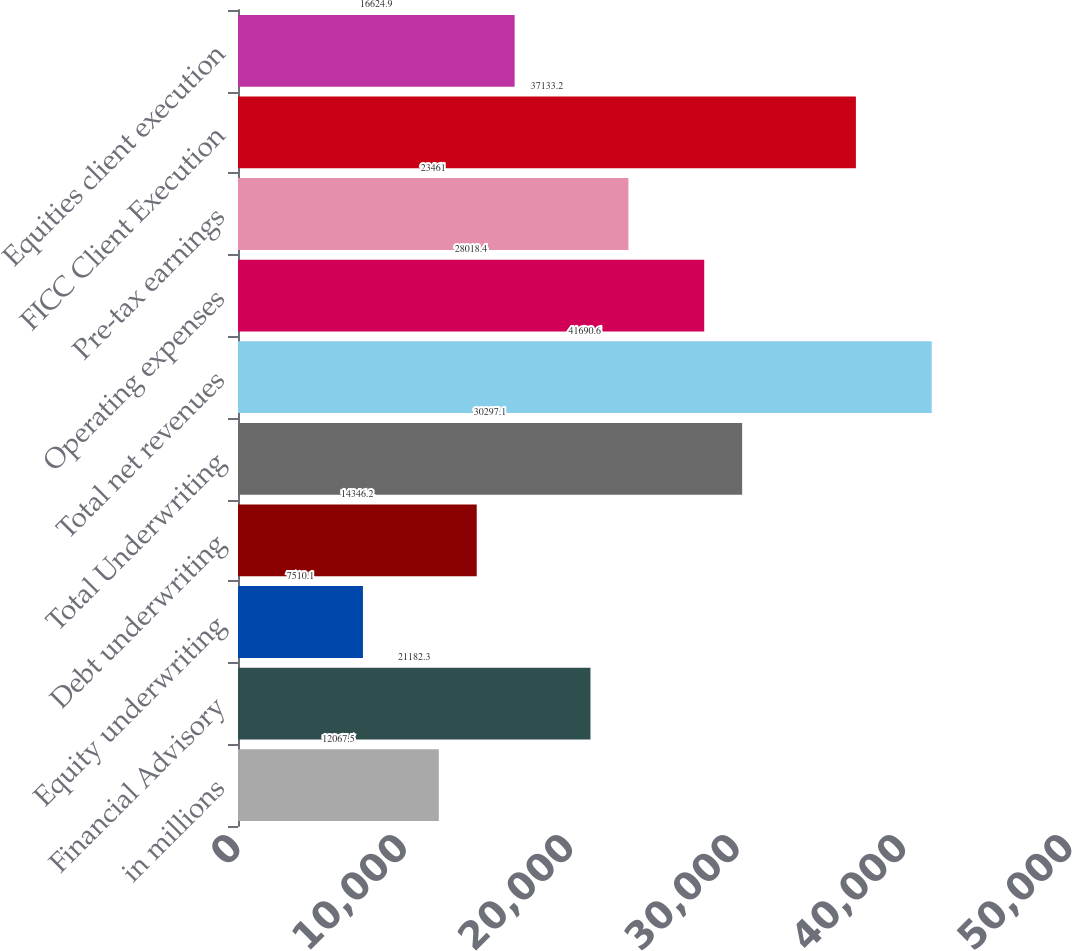<chart> <loc_0><loc_0><loc_500><loc_500><bar_chart><fcel>in millions<fcel>Financial Advisory<fcel>Equity underwriting<fcel>Debt underwriting<fcel>Total Underwriting<fcel>Total net revenues<fcel>Operating expenses<fcel>Pre-tax earnings<fcel>FICC Client Execution<fcel>Equities client execution<nl><fcel>12067.5<fcel>21182.3<fcel>7510.1<fcel>14346.2<fcel>30297.1<fcel>41690.6<fcel>28018.4<fcel>23461<fcel>37133.2<fcel>16624.9<nl></chart> 